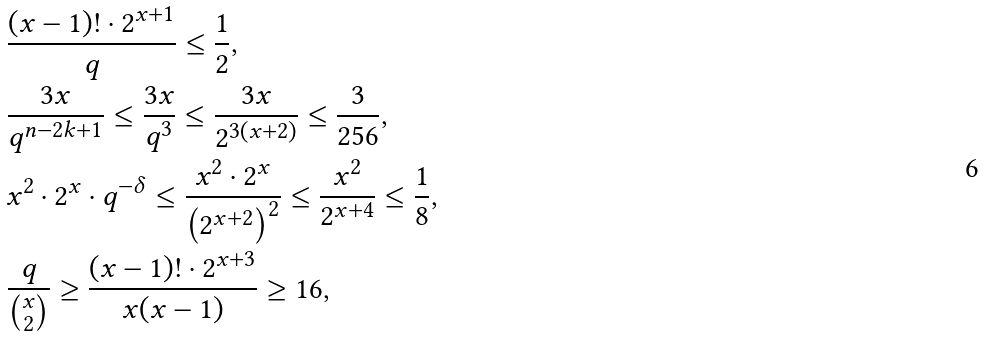<formula> <loc_0><loc_0><loc_500><loc_500>& \frac { ( x - 1 ) ! \cdot 2 ^ { x + 1 } } { q } \leq \frac { 1 } { 2 } , \\ & \frac { 3 x } { q ^ { n - 2 k + 1 } } \leq \frac { 3 x } { q ^ { 3 } } \leq \frac { 3 x } { 2 ^ { 3 ( x + 2 ) } } \leq \frac { 3 } { 2 5 6 } , \\ & x ^ { 2 } \cdot 2 ^ { x } \cdot q ^ { - \delta } \leq \frac { x ^ { 2 } \cdot 2 ^ { x } } { \left ( 2 ^ { x + 2 } \right ) ^ { 2 } } \leq \frac { x ^ { 2 } } { 2 ^ { x + 4 } } \leq \frac { 1 } { 8 } , \\ & \frac { q } { \binom { x } { 2 } } \geq \frac { ( x - 1 ) ! \cdot 2 ^ { x + 3 } } { x ( x - 1 ) } \geq 1 6 ,</formula> 